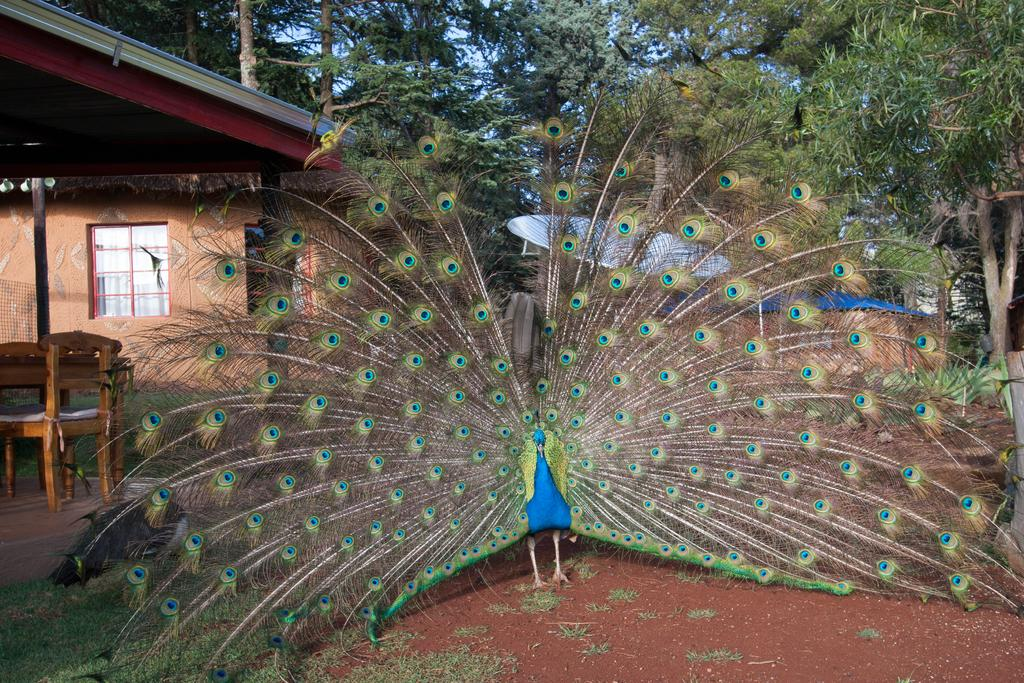What animal is on the ground in the image? There is a peacock on the ground in the image. What furniture is present in the image? There is a table and a chair in the image. What type of house is visible in the image? There is a house with glass windows in the image. What can be seen in the background of the image? There are trees in the background of the image. Can you see a person driving a car in the image? There is no person or car present in the image. How many sheep are visible in the image? There are no sheep present in the image. 